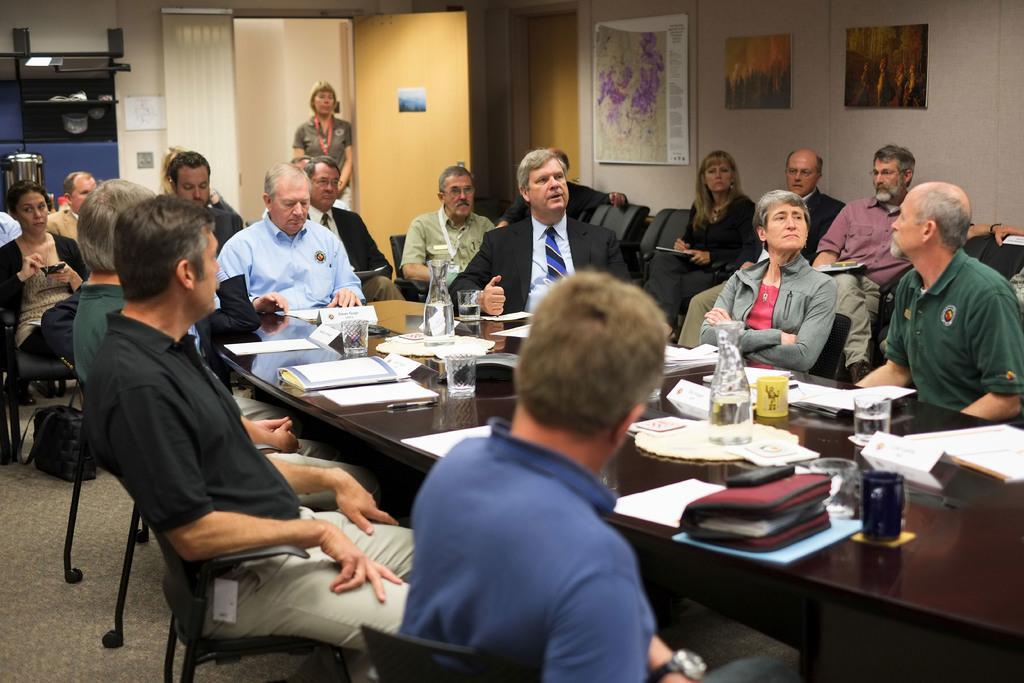Describe this image in one or two sentences. There are group of people sat on chair around the table. The table has many papers,bottles,glasses on it. In the back there is a lady stood near the door and over the wall there are some paintings. 